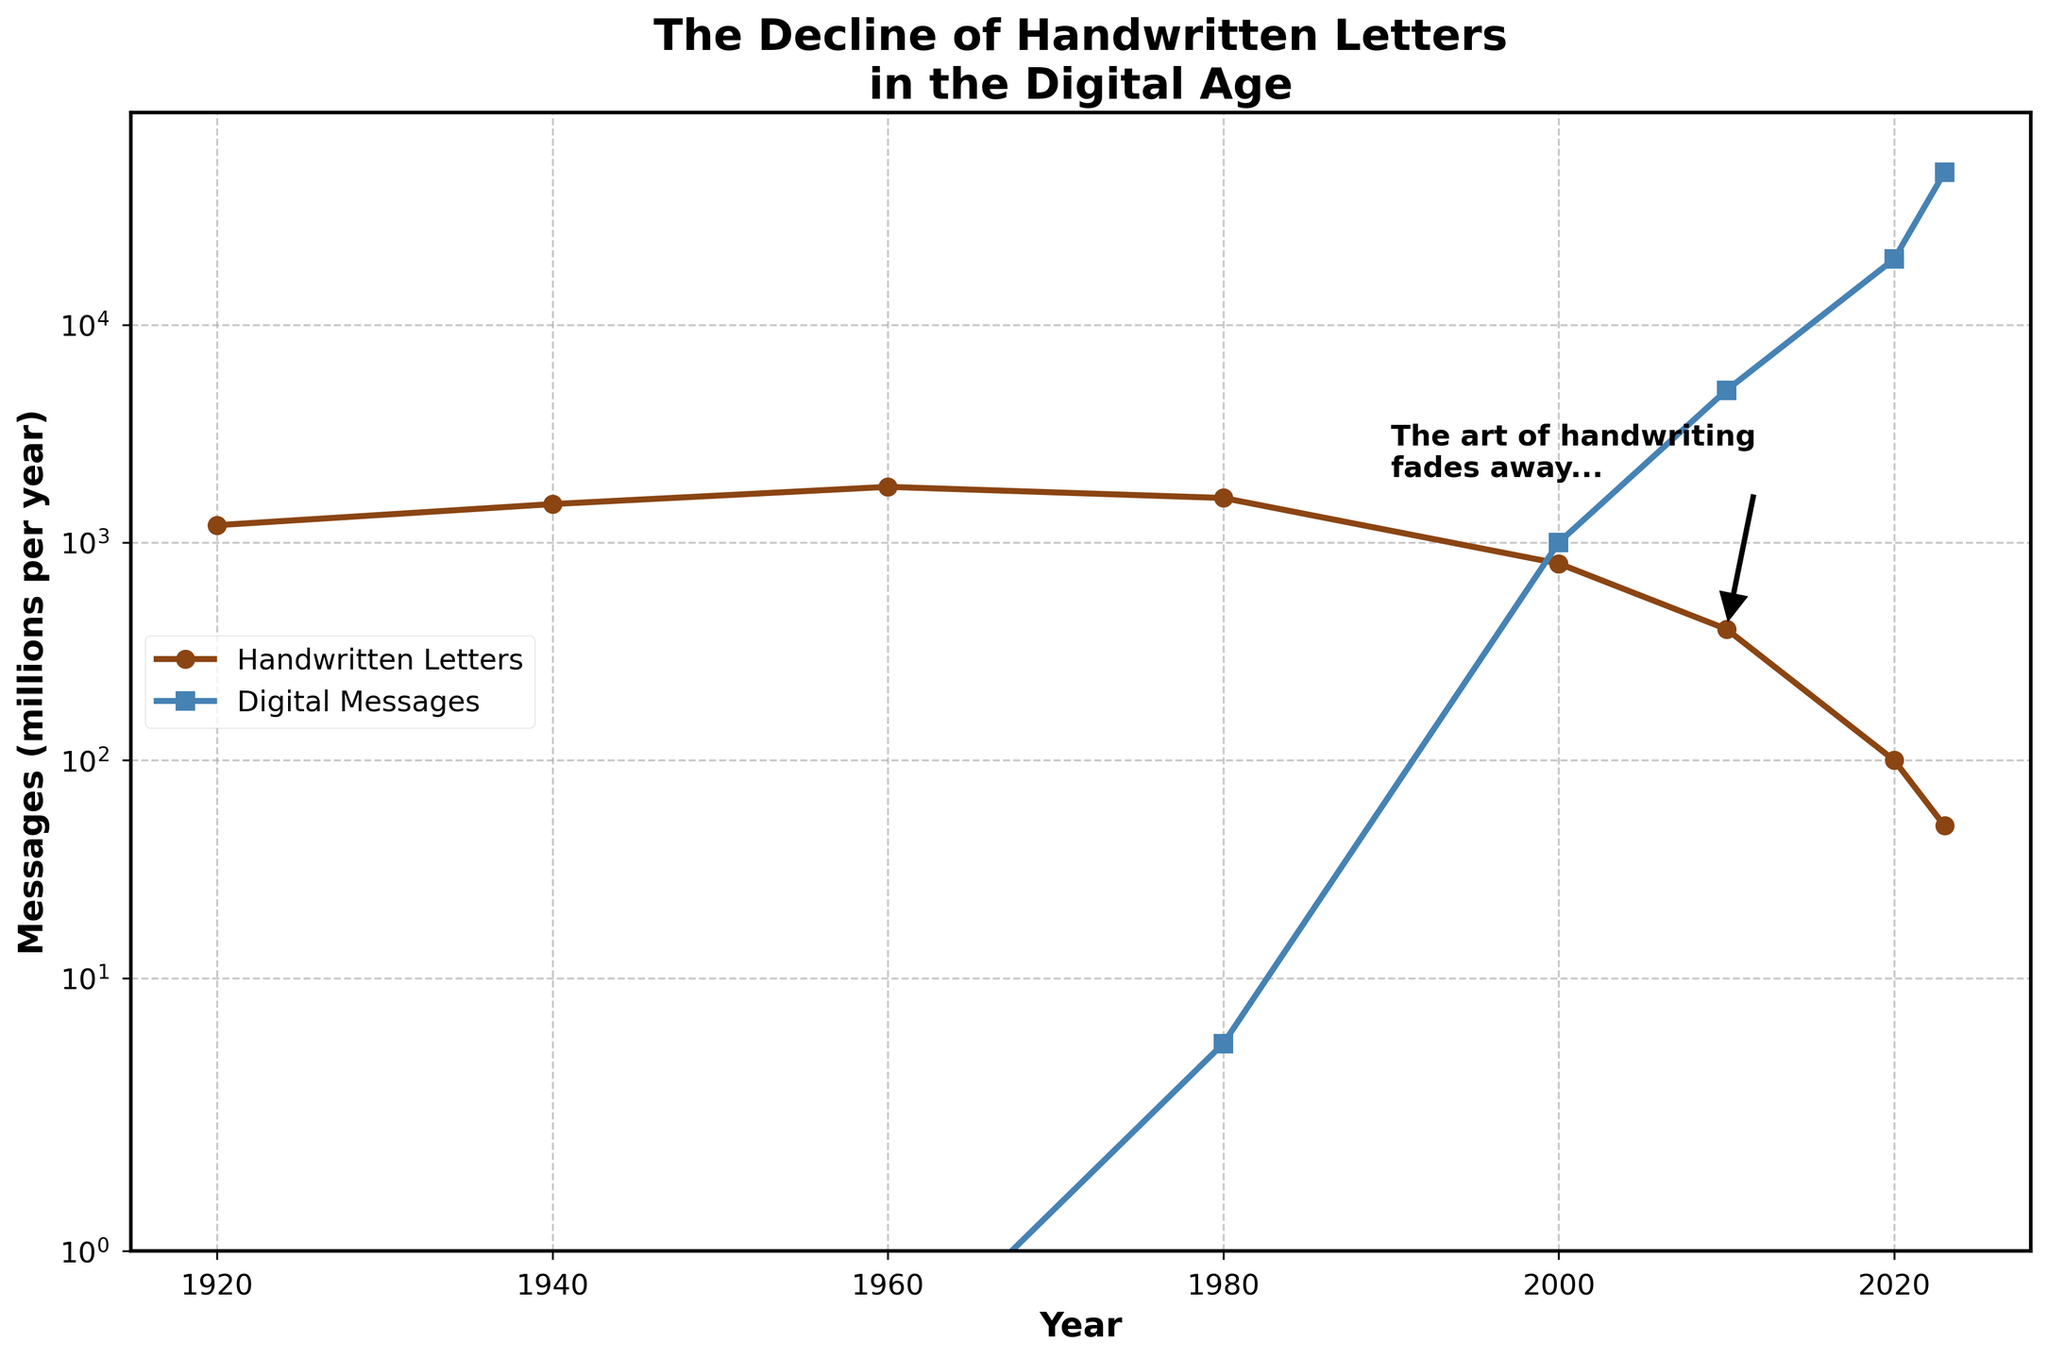What's the overall trend for handwritten letters from 1920 to 2023? The overall trend shows a decrease in handwritten letter correspondence. It starts at 1200 million in 1920 and ends at 50 million in 2023. The drop is particularly sharp after 1980.
Answer: Decrease In which year did digital messages surpass handwritten letters in volume? According to the plot, digital messages surpassed handwritten letters in 2000. In that year, digital messages reached 1000 million, whereas handwritten letters fell to 800 million.
Answer: 2000 Compare the volumes of handwritten letters and digital messages in 2020. Which one was higher and by how much? In 2020, handwritten letters were at 100 million, while digital messages were at 20,000 million. Thus, digital messages were higher by 19,900 million.
Answer: Digital messages by 19,900 million What's the average annual number of handwritten letters for the 20th century (1920 to 2000)? To find the average, sum the values for 1920, 1940, 1960, 1980, and 2000, then divide by 5. (1200 + 1500 + 1800 + 1600 + 800) / 5 = 1520.
Answer: 1520 million Describe the visual annotation in the plot. What is its purpose? The annotation "The art of handwriting fades away..." is located near the 2010 data point for handwritten letters. It is meant to highlight the decline and invoke emotional reflection on the loss of handwritten communication.
Answer: Highlights decline of handwritten letters What can be said about the rate of decrease in handwritten letters from 1980 to 2000 compared to 2000 to 2023? From 1980 to 2000, handwritten letters dropped from 1600 to 800 million (a reduction of 800 million over 20 years). From 2000 to 2023, they fell from 800 to 50 million (a reduction of 750 million over 23 years). The rate is slightly faster in the first period.
Answer: Faster from 1980 to 2000 What is the visual color coding for the lines representing handwritten letters and digital messages? Handwritten letters are represented with a brown line, and digital messages with a blue one. This distinct color coding helps in visually distinguishing between the two types of correspondence.
Answer: Brown for handwritten letters, blue for digital messages What's the ratio of digital messages to handwritten letters in 2023? In 2023, the volume of digital messages is 50,000 million, and handwritten letters is 50 million. The ratio is 50,000 / 50 = 1000.
Answer: 1000 What does the dotted grid in the plot signify? The dotted grid in both major and minor ticks provides a visual aid to read values accurately from the graph. It doesn't represent data but helps locate exact data points.
Answer: Visual aid for reading values Compare the handwritten letter volumes between 1940 and 1980. What is the change? In 1940, the volume was 1500 million, and in 1980, it was 1600 million. The change is an increase of 100 million over these 40 years.
Answer: Increase by 100 million 